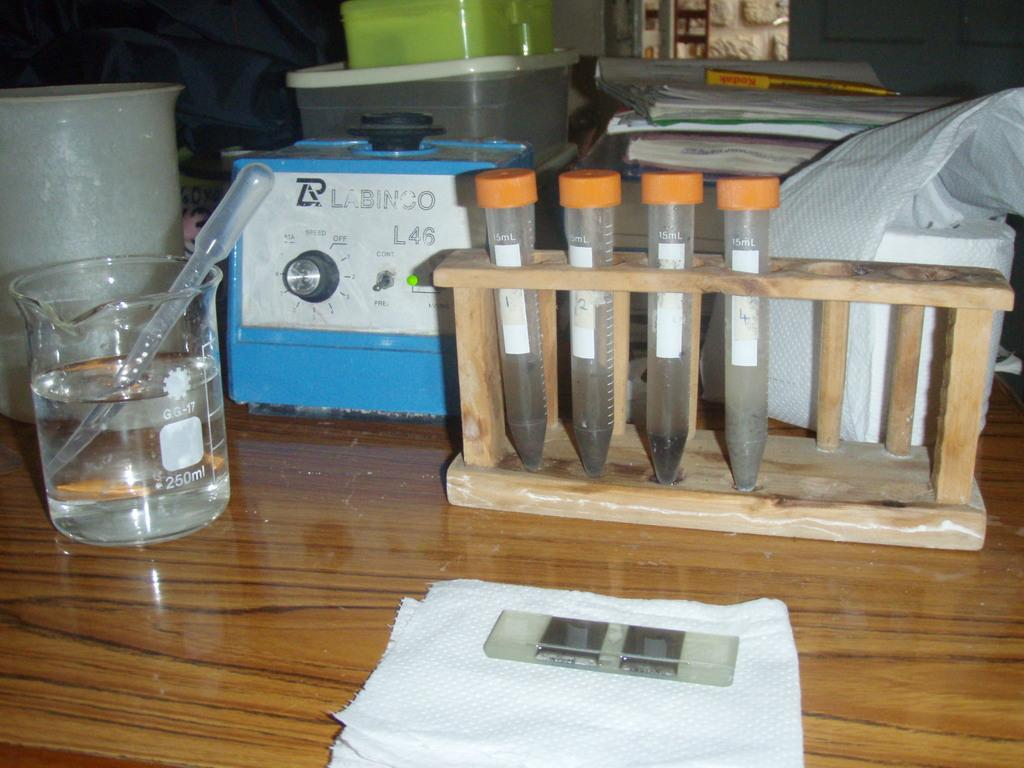<image>
Give a short and clear explanation of the subsequent image. A blue Labinco piece of equipment is in the middle of a beaker and test tubes on a table. 